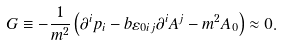<formula> <loc_0><loc_0><loc_500><loc_500>G \equiv - \frac { 1 } { m ^ { 2 } } \left ( \partial ^ { i } p _ { i } - b \varepsilon _ { 0 i j } \partial ^ { i } A ^ { j } - m ^ { 2 } A _ { 0 } \right ) \approx 0 .</formula> 